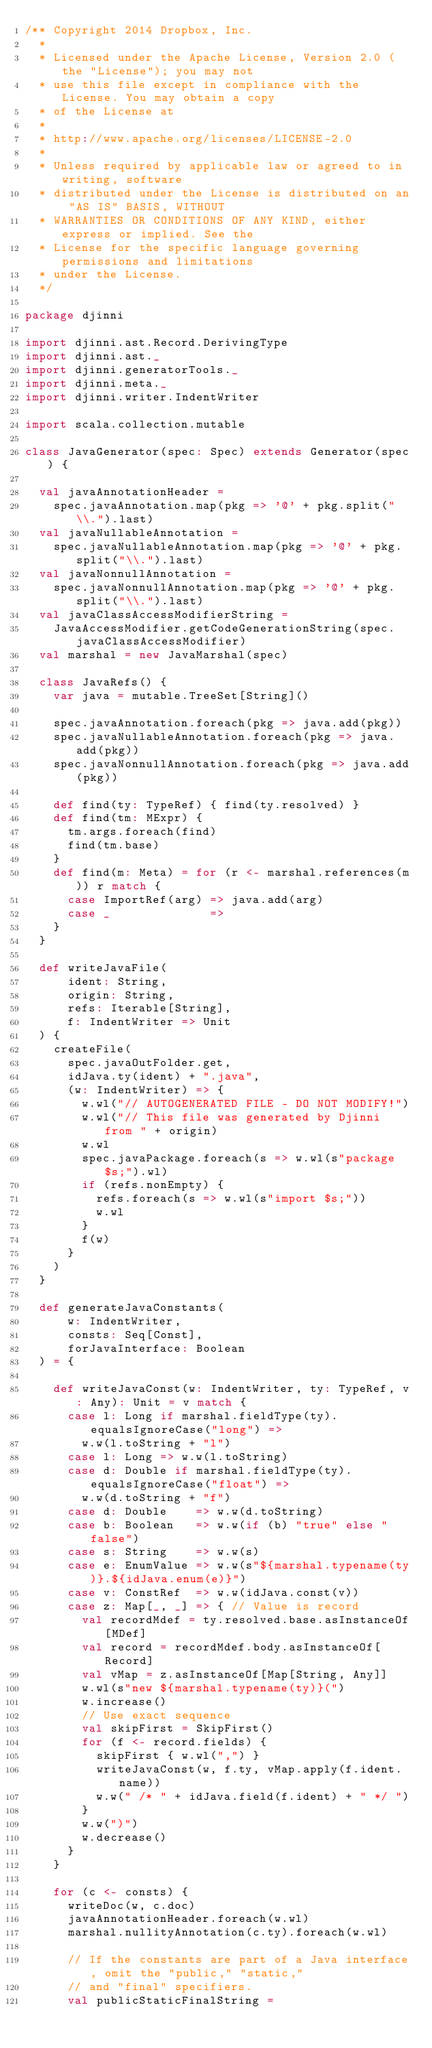<code> <loc_0><loc_0><loc_500><loc_500><_Scala_>/** Copyright 2014 Dropbox, Inc.
  *
  * Licensed under the Apache License, Version 2.0 (the "License"); you may not
  * use this file except in compliance with the License. You may obtain a copy
  * of the License at
  *
  * http://www.apache.org/licenses/LICENSE-2.0
  *
  * Unless required by applicable law or agreed to in writing, software
  * distributed under the License is distributed on an "AS IS" BASIS, WITHOUT
  * WARRANTIES OR CONDITIONS OF ANY KIND, either express or implied. See the
  * License for the specific language governing permissions and limitations
  * under the License.
  */

package djinni

import djinni.ast.Record.DerivingType
import djinni.ast._
import djinni.generatorTools._
import djinni.meta._
import djinni.writer.IndentWriter

import scala.collection.mutable

class JavaGenerator(spec: Spec) extends Generator(spec) {

  val javaAnnotationHeader =
    spec.javaAnnotation.map(pkg => '@' + pkg.split("\\.").last)
  val javaNullableAnnotation =
    spec.javaNullableAnnotation.map(pkg => '@' + pkg.split("\\.").last)
  val javaNonnullAnnotation =
    spec.javaNonnullAnnotation.map(pkg => '@' + pkg.split("\\.").last)
  val javaClassAccessModifierString =
    JavaAccessModifier.getCodeGenerationString(spec.javaClassAccessModifier)
  val marshal = new JavaMarshal(spec)

  class JavaRefs() {
    var java = mutable.TreeSet[String]()

    spec.javaAnnotation.foreach(pkg => java.add(pkg))
    spec.javaNullableAnnotation.foreach(pkg => java.add(pkg))
    spec.javaNonnullAnnotation.foreach(pkg => java.add(pkg))

    def find(ty: TypeRef) { find(ty.resolved) }
    def find(tm: MExpr) {
      tm.args.foreach(find)
      find(tm.base)
    }
    def find(m: Meta) = for (r <- marshal.references(m)) r match {
      case ImportRef(arg) => java.add(arg)
      case _              =>
    }
  }

  def writeJavaFile(
      ident: String,
      origin: String,
      refs: Iterable[String],
      f: IndentWriter => Unit
  ) {
    createFile(
      spec.javaOutFolder.get,
      idJava.ty(ident) + ".java",
      (w: IndentWriter) => {
        w.wl("// AUTOGENERATED FILE - DO NOT MODIFY!")
        w.wl("// This file was generated by Djinni from " + origin)
        w.wl
        spec.javaPackage.foreach(s => w.wl(s"package $s;").wl)
        if (refs.nonEmpty) {
          refs.foreach(s => w.wl(s"import $s;"))
          w.wl
        }
        f(w)
      }
    )
  }

  def generateJavaConstants(
      w: IndentWriter,
      consts: Seq[Const],
      forJavaInterface: Boolean
  ) = {

    def writeJavaConst(w: IndentWriter, ty: TypeRef, v: Any): Unit = v match {
      case l: Long if marshal.fieldType(ty).equalsIgnoreCase("long") =>
        w.w(l.toString + "l")
      case l: Long => w.w(l.toString)
      case d: Double if marshal.fieldType(ty).equalsIgnoreCase("float") =>
        w.w(d.toString + "f")
      case d: Double    => w.w(d.toString)
      case b: Boolean   => w.w(if (b) "true" else "false")
      case s: String    => w.w(s)
      case e: EnumValue => w.w(s"${marshal.typename(ty)}.${idJava.enum(e)}")
      case v: ConstRef  => w.w(idJava.const(v))
      case z: Map[_, _] => { // Value is record
        val recordMdef = ty.resolved.base.asInstanceOf[MDef]
        val record = recordMdef.body.asInstanceOf[Record]
        val vMap = z.asInstanceOf[Map[String, Any]]
        w.wl(s"new ${marshal.typename(ty)}(")
        w.increase()
        // Use exact sequence
        val skipFirst = SkipFirst()
        for (f <- record.fields) {
          skipFirst { w.wl(",") }
          writeJavaConst(w, f.ty, vMap.apply(f.ident.name))
          w.w(" /* " + idJava.field(f.ident) + " */ ")
        }
        w.w(")")
        w.decrease()
      }
    }

    for (c <- consts) {
      writeDoc(w, c.doc)
      javaAnnotationHeader.foreach(w.wl)
      marshal.nullityAnnotation(c.ty).foreach(w.wl)

      // If the constants are part of a Java interface, omit the "public," "static,"
      // and "final" specifiers.
      val publicStaticFinalString =</code> 